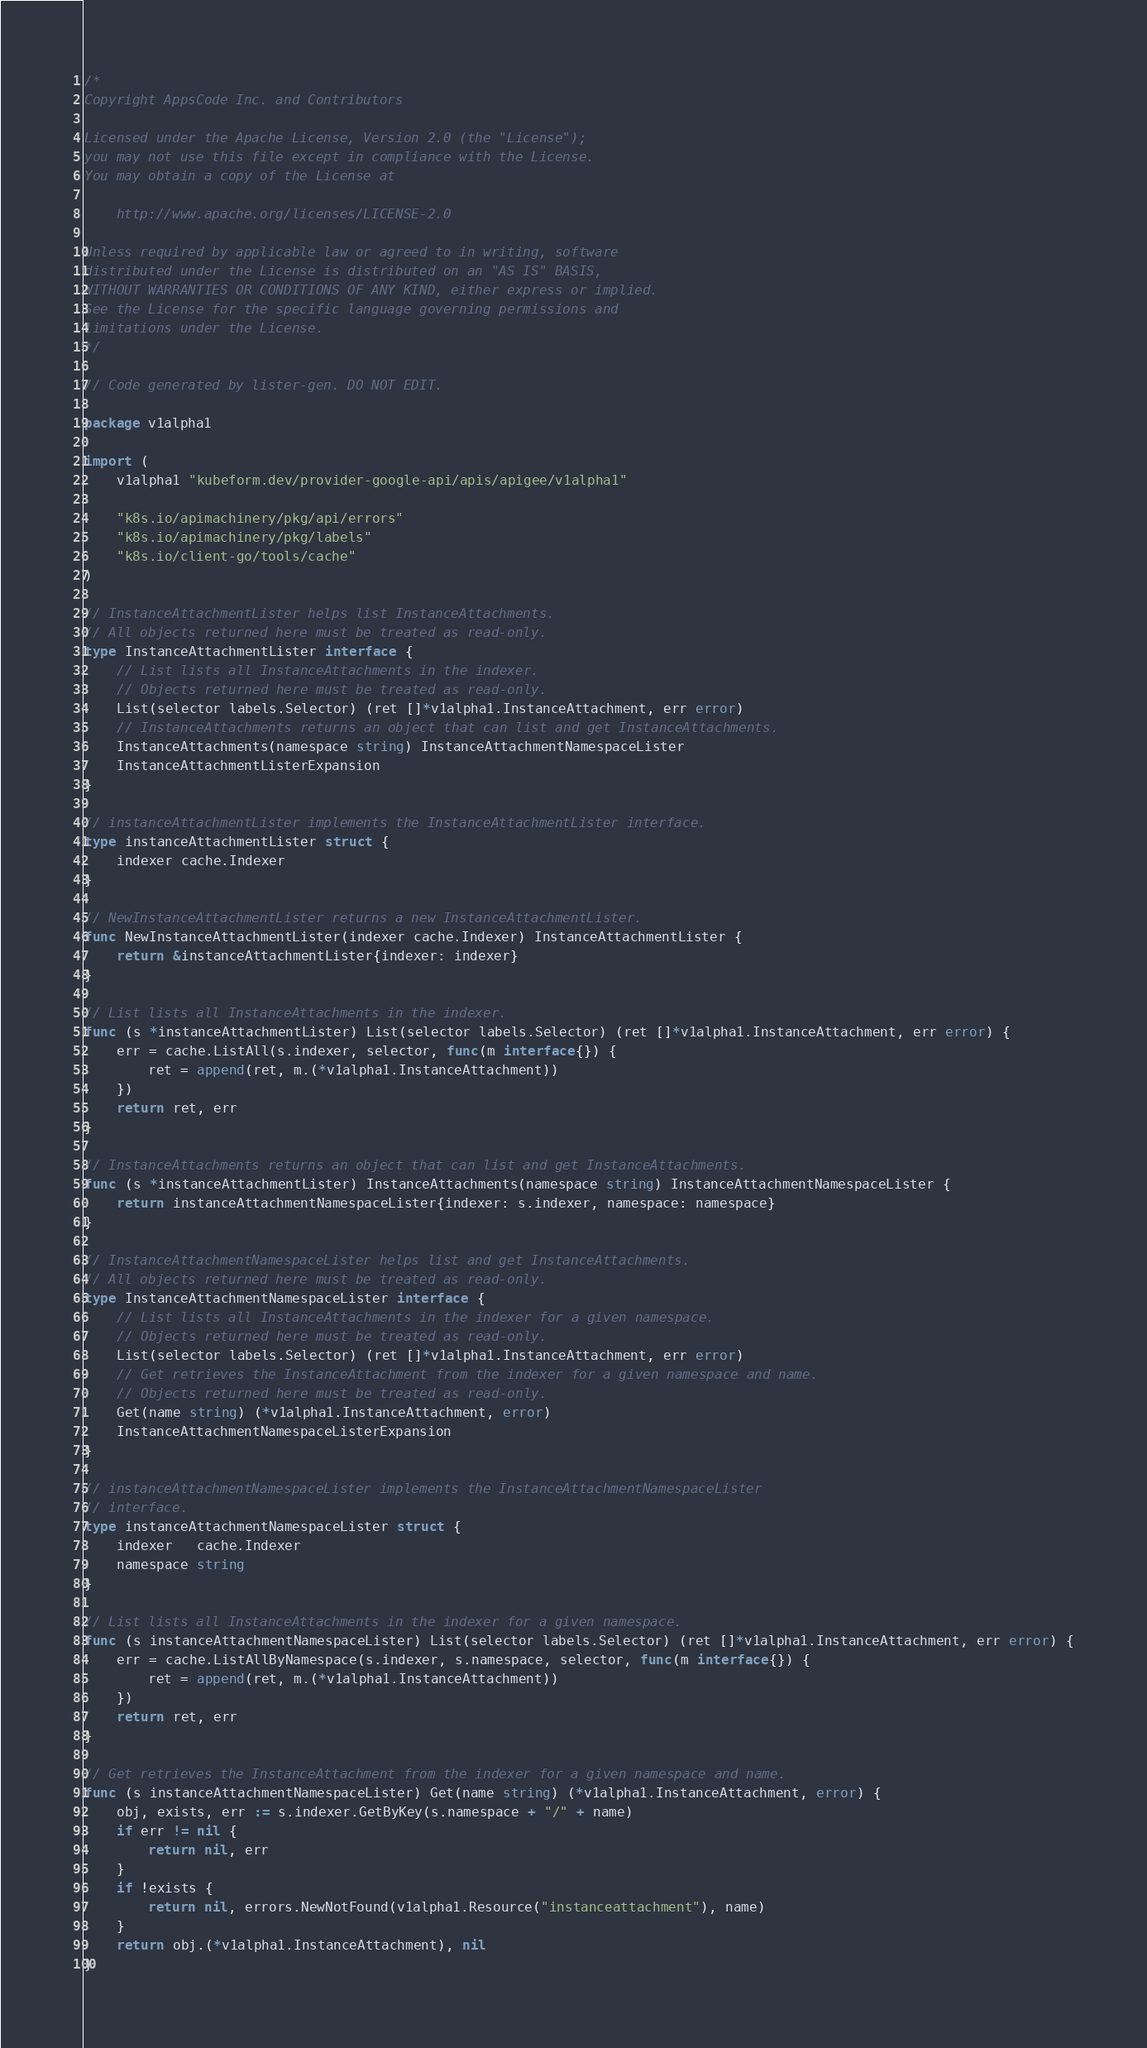<code> <loc_0><loc_0><loc_500><loc_500><_Go_>/*
Copyright AppsCode Inc. and Contributors

Licensed under the Apache License, Version 2.0 (the "License");
you may not use this file except in compliance with the License.
You may obtain a copy of the License at

    http://www.apache.org/licenses/LICENSE-2.0

Unless required by applicable law or agreed to in writing, software
distributed under the License is distributed on an "AS IS" BASIS,
WITHOUT WARRANTIES OR CONDITIONS OF ANY KIND, either express or implied.
See the License for the specific language governing permissions and
limitations under the License.
*/

// Code generated by lister-gen. DO NOT EDIT.

package v1alpha1

import (
	v1alpha1 "kubeform.dev/provider-google-api/apis/apigee/v1alpha1"

	"k8s.io/apimachinery/pkg/api/errors"
	"k8s.io/apimachinery/pkg/labels"
	"k8s.io/client-go/tools/cache"
)

// InstanceAttachmentLister helps list InstanceAttachments.
// All objects returned here must be treated as read-only.
type InstanceAttachmentLister interface {
	// List lists all InstanceAttachments in the indexer.
	// Objects returned here must be treated as read-only.
	List(selector labels.Selector) (ret []*v1alpha1.InstanceAttachment, err error)
	// InstanceAttachments returns an object that can list and get InstanceAttachments.
	InstanceAttachments(namespace string) InstanceAttachmentNamespaceLister
	InstanceAttachmentListerExpansion
}

// instanceAttachmentLister implements the InstanceAttachmentLister interface.
type instanceAttachmentLister struct {
	indexer cache.Indexer
}

// NewInstanceAttachmentLister returns a new InstanceAttachmentLister.
func NewInstanceAttachmentLister(indexer cache.Indexer) InstanceAttachmentLister {
	return &instanceAttachmentLister{indexer: indexer}
}

// List lists all InstanceAttachments in the indexer.
func (s *instanceAttachmentLister) List(selector labels.Selector) (ret []*v1alpha1.InstanceAttachment, err error) {
	err = cache.ListAll(s.indexer, selector, func(m interface{}) {
		ret = append(ret, m.(*v1alpha1.InstanceAttachment))
	})
	return ret, err
}

// InstanceAttachments returns an object that can list and get InstanceAttachments.
func (s *instanceAttachmentLister) InstanceAttachments(namespace string) InstanceAttachmentNamespaceLister {
	return instanceAttachmentNamespaceLister{indexer: s.indexer, namespace: namespace}
}

// InstanceAttachmentNamespaceLister helps list and get InstanceAttachments.
// All objects returned here must be treated as read-only.
type InstanceAttachmentNamespaceLister interface {
	// List lists all InstanceAttachments in the indexer for a given namespace.
	// Objects returned here must be treated as read-only.
	List(selector labels.Selector) (ret []*v1alpha1.InstanceAttachment, err error)
	// Get retrieves the InstanceAttachment from the indexer for a given namespace and name.
	// Objects returned here must be treated as read-only.
	Get(name string) (*v1alpha1.InstanceAttachment, error)
	InstanceAttachmentNamespaceListerExpansion
}

// instanceAttachmentNamespaceLister implements the InstanceAttachmentNamespaceLister
// interface.
type instanceAttachmentNamespaceLister struct {
	indexer   cache.Indexer
	namespace string
}

// List lists all InstanceAttachments in the indexer for a given namespace.
func (s instanceAttachmentNamespaceLister) List(selector labels.Selector) (ret []*v1alpha1.InstanceAttachment, err error) {
	err = cache.ListAllByNamespace(s.indexer, s.namespace, selector, func(m interface{}) {
		ret = append(ret, m.(*v1alpha1.InstanceAttachment))
	})
	return ret, err
}

// Get retrieves the InstanceAttachment from the indexer for a given namespace and name.
func (s instanceAttachmentNamespaceLister) Get(name string) (*v1alpha1.InstanceAttachment, error) {
	obj, exists, err := s.indexer.GetByKey(s.namespace + "/" + name)
	if err != nil {
		return nil, err
	}
	if !exists {
		return nil, errors.NewNotFound(v1alpha1.Resource("instanceattachment"), name)
	}
	return obj.(*v1alpha1.InstanceAttachment), nil
}
</code> 